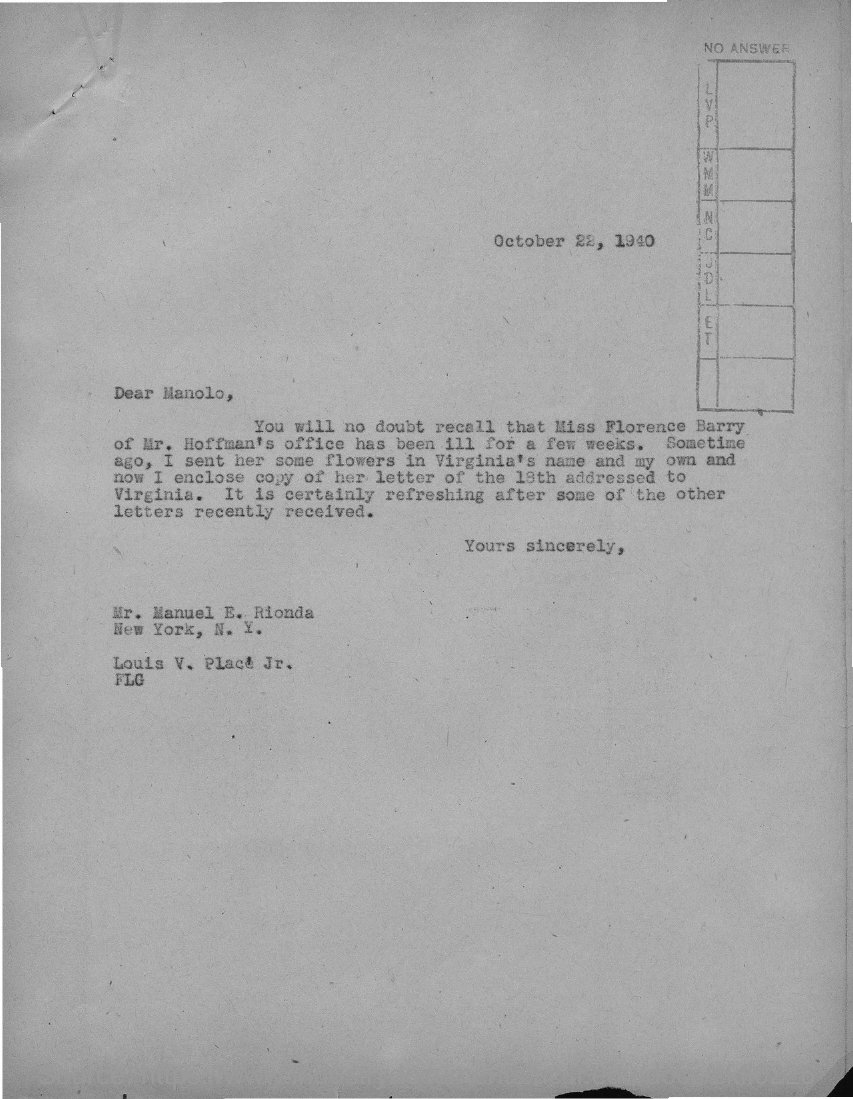What is the date on the document?
Ensure brevity in your answer.  OCTOBER 22, 1940. To Whom is this letter addressed to?
Your answer should be very brief. Manolo. 